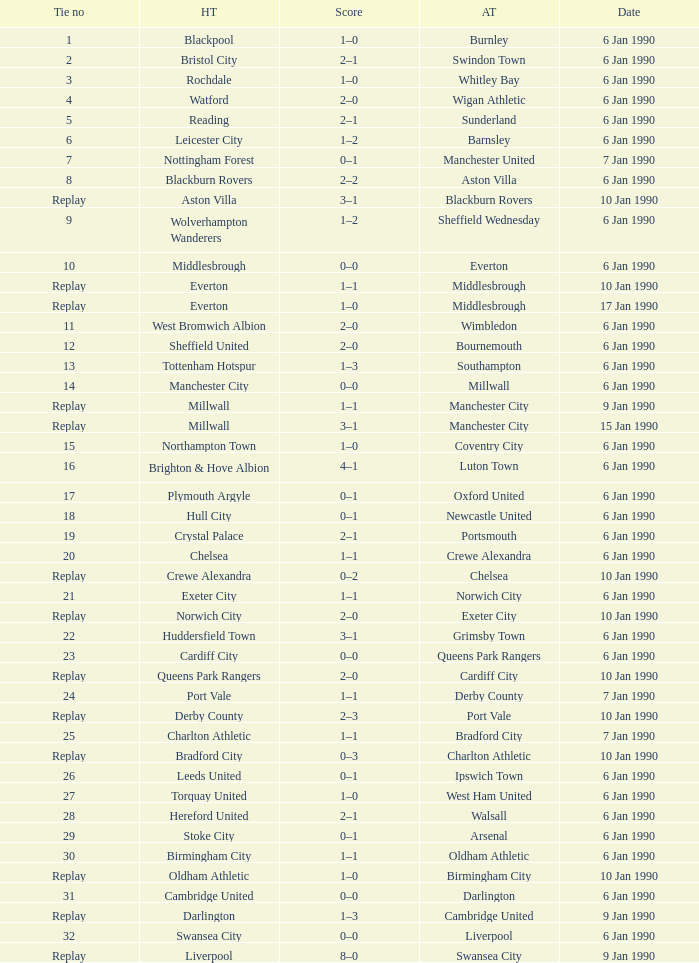What is the tie no of the game where exeter city was the home team? 21.0. 